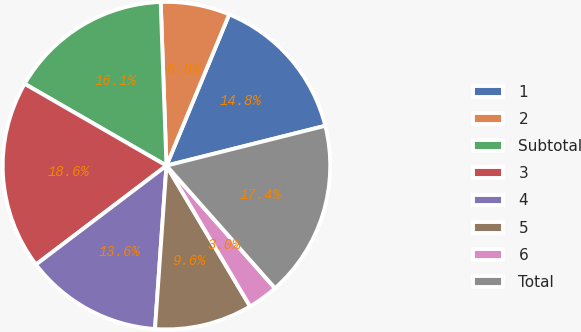<chart> <loc_0><loc_0><loc_500><loc_500><pie_chart><fcel>1<fcel>2<fcel>Subtotal<fcel>3<fcel>4<fcel>5<fcel>6<fcel>Total<nl><fcel>14.83%<fcel>6.82%<fcel>16.11%<fcel>18.65%<fcel>13.56%<fcel>9.65%<fcel>3.0%<fcel>17.38%<nl></chart> 